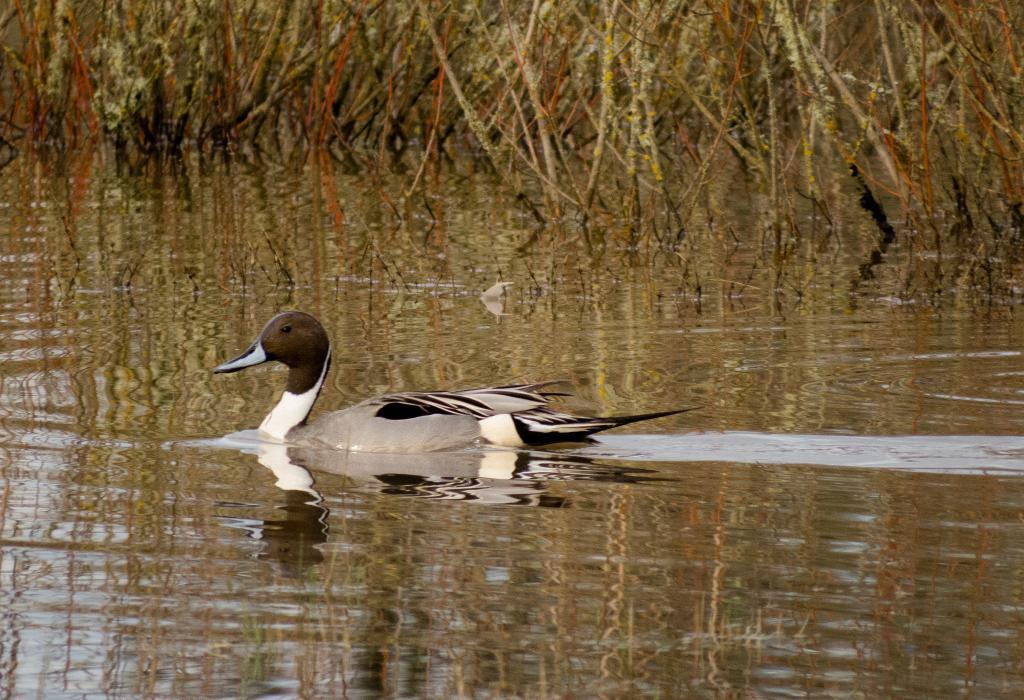What type of animal is in the image? There is a bird in the image. Where is the bird located? The bird is on the water. What else can be seen in the image besides the bird? There are plants visible in the image. What type of parcel is being delivered by the bird in the image? There is no parcel present in the image, and the bird is not delivering anything. 